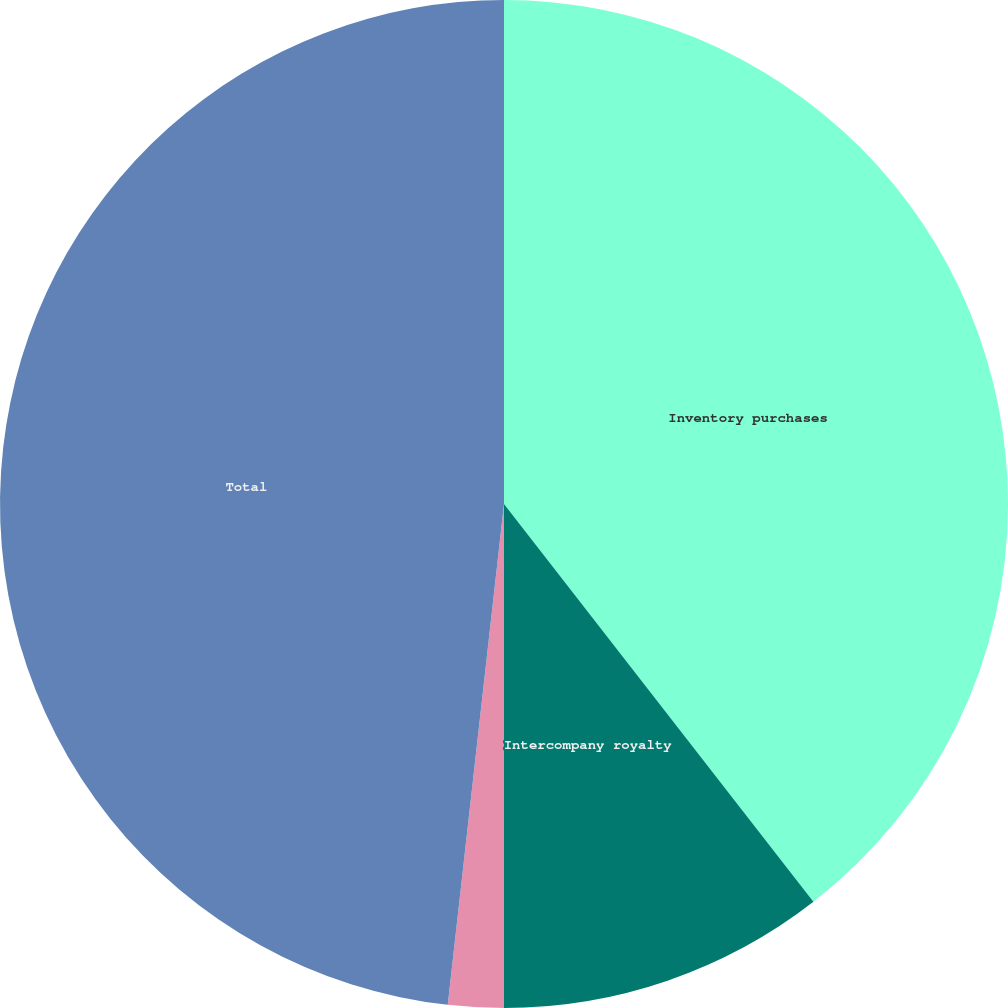Convert chart to OTSL. <chart><loc_0><loc_0><loc_500><loc_500><pie_chart><fcel>Inventory purchases<fcel>Intercompany royalty<fcel>Other<fcel>Total<nl><fcel>39.48%<fcel>10.52%<fcel>1.78%<fcel>48.22%<nl></chart> 